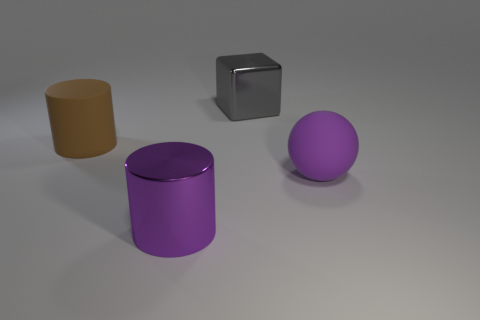Add 4 purple rubber balls. How many objects exist? 8 Subtract all cubes. How many objects are left? 3 Subtract 0 brown blocks. How many objects are left? 4 Subtract all rubber cylinders. Subtract all matte balls. How many objects are left? 2 Add 3 large purple objects. How many large purple objects are left? 5 Add 4 small matte objects. How many small matte objects exist? 4 